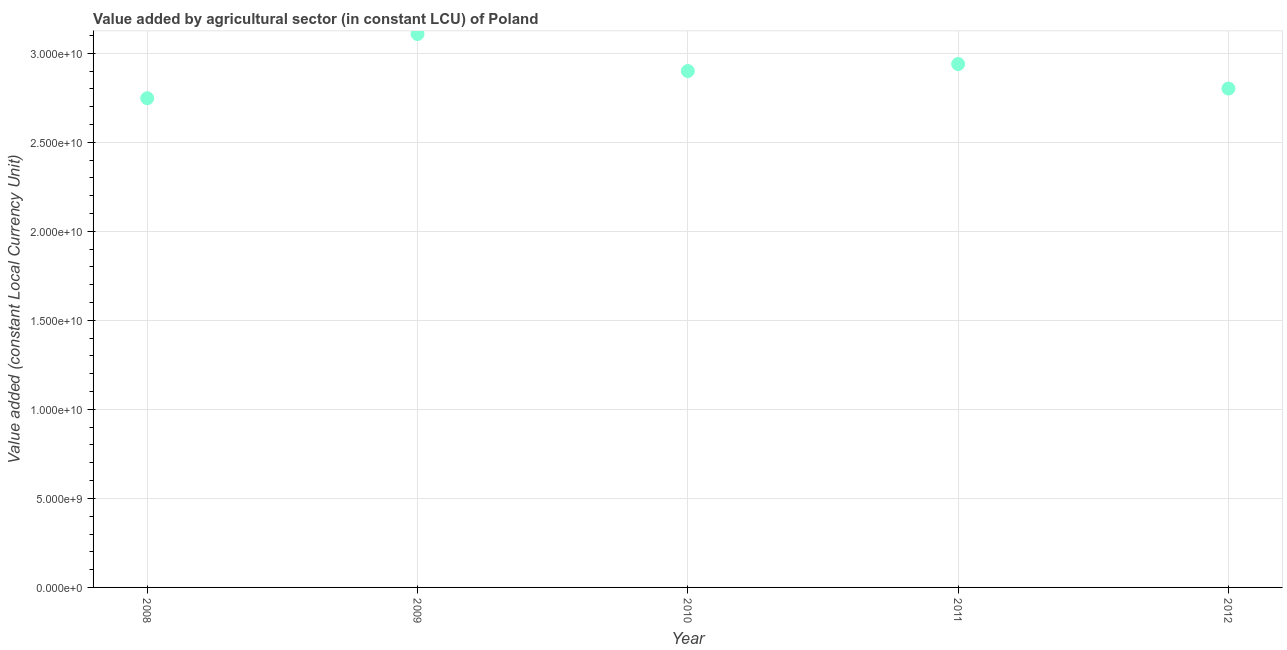What is the value added by agriculture sector in 2011?
Make the answer very short. 2.94e+1. Across all years, what is the maximum value added by agriculture sector?
Ensure brevity in your answer.  3.11e+1. Across all years, what is the minimum value added by agriculture sector?
Your answer should be compact. 2.75e+1. In which year was the value added by agriculture sector maximum?
Your response must be concise. 2009. In which year was the value added by agriculture sector minimum?
Offer a very short reply. 2008. What is the sum of the value added by agriculture sector?
Offer a very short reply. 1.45e+11. What is the difference between the value added by agriculture sector in 2009 and 2011?
Your answer should be compact. 1.69e+09. What is the average value added by agriculture sector per year?
Keep it short and to the point. 2.90e+1. What is the median value added by agriculture sector?
Your response must be concise. 2.90e+1. In how many years, is the value added by agriculture sector greater than 16000000000 LCU?
Your answer should be very brief. 5. What is the ratio of the value added by agriculture sector in 2008 to that in 2010?
Your answer should be compact. 0.95. Is the difference between the value added by agriculture sector in 2008 and 2009 greater than the difference between any two years?
Your answer should be very brief. Yes. What is the difference between the highest and the second highest value added by agriculture sector?
Provide a succinct answer. 1.69e+09. Is the sum of the value added by agriculture sector in 2008 and 2011 greater than the maximum value added by agriculture sector across all years?
Keep it short and to the point. Yes. What is the difference between the highest and the lowest value added by agriculture sector?
Offer a terse response. 3.60e+09. Does the value added by agriculture sector monotonically increase over the years?
Give a very brief answer. No. How many dotlines are there?
Offer a very short reply. 1. What is the title of the graph?
Make the answer very short. Value added by agricultural sector (in constant LCU) of Poland. What is the label or title of the X-axis?
Your response must be concise. Year. What is the label or title of the Y-axis?
Your response must be concise. Value added (constant Local Currency Unit). What is the Value added (constant Local Currency Unit) in 2008?
Your response must be concise. 2.75e+1. What is the Value added (constant Local Currency Unit) in 2009?
Your answer should be compact. 3.11e+1. What is the Value added (constant Local Currency Unit) in 2010?
Ensure brevity in your answer.  2.90e+1. What is the Value added (constant Local Currency Unit) in 2011?
Your answer should be very brief. 2.94e+1. What is the Value added (constant Local Currency Unit) in 2012?
Keep it short and to the point. 2.80e+1. What is the difference between the Value added (constant Local Currency Unit) in 2008 and 2009?
Keep it short and to the point. -3.60e+09. What is the difference between the Value added (constant Local Currency Unit) in 2008 and 2010?
Offer a very short reply. -1.53e+09. What is the difference between the Value added (constant Local Currency Unit) in 2008 and 2011?
Your answer should be very brief. -1.92e+09. What is the difference between the Value added (constant Local Currency Unit) in 2008 and 2012?
Offer a terse response. -5.42e+08. What is the difference between the Value added (constant Local Currency Unit) in 2009 and 2010?
Provide a short and direct response. 2.08e+09. What is the difference between the Value added (constant Local Currency Unit) in 2009 and 2011?
Ensure brevity in your answer.  1.69e+09. What is the difference between the Value added (constant Local Currency Unit) in 2009 and 2012?
Your answer should be compact. 3.06e+09. What is the difference between the Value added (constant Local Currency Unit) in 2010 and 2011?
Ensure brevity in your answer.  -3.93e+08. What is the difference between the Value added (constant Local Currency Unit) in 2010 and 2012?
Offer a terse response. 9.84e+08. What is the difference between the Value added (constant Local Currency Unit) in 2011 and 2012?
Offer a very short reply. 1.38e+09. What is the ratio of the Value added (constant Local Currency Unit) in 2008 to that in 2009?
Ensure brevity in your answer.  0.88. What is the ratio of the Value added (constant Local Currency Unit) in 2008 to that in 2010?
Your answer should be very brief. 0.95. What is the ratio of the Value added (constant Local Currency Unit) in 2008 to that in 2011?
Offer a very short reply. 0.94. What is the ratio of the Value added (constant Local Currency Unit) in 2008 to that in 2012?
Your response must be concise. 0.98. What is the ratio of the Value added (constant Local Currency Unit) in 2009 to that in 2010?
Provide a short and direct response. 1.07. What is the ratio of the Value added (constant Local Currency Unit) in 2009 to that in 2011?
Keep it short and to the point. 1.06. What is the ratio of the Value added (constant Local Currency Unit) in 2009 to that in 2012?
Make the answer very short. 1.11. What is the ratio of the Value added (constant Local Currency Unit) in 2010 to that in 2012?
Ensure brevity in your answer.  1.03. What is the ratio of the Value added (constant Local Currency Unit) in 2011 to that in 2012?
Offer a terse response. 1.05. 